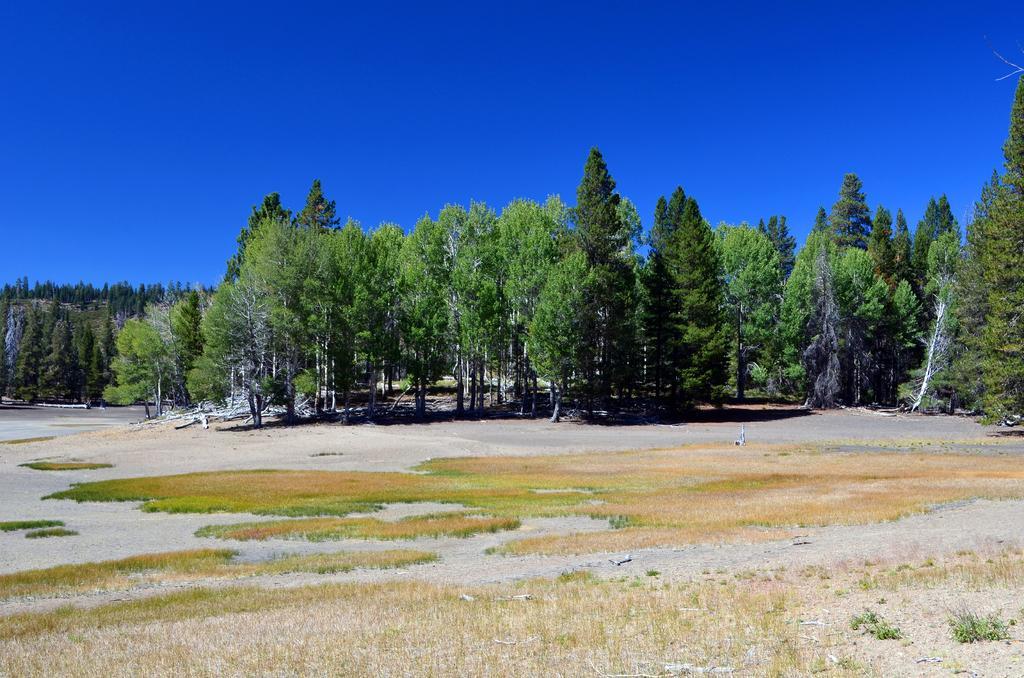Describe this image in one or two sentences. In the foreground of this picture, we can see the grassland, trees and on the top we can see the sky. 